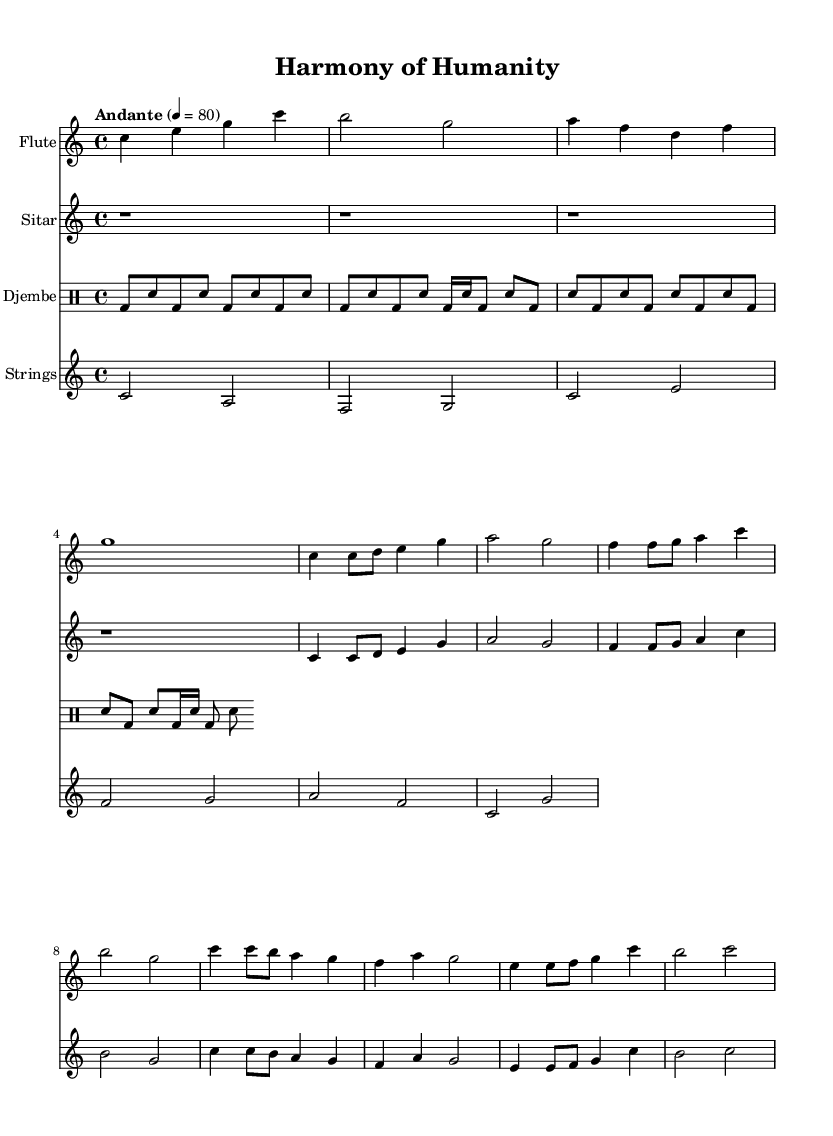What is the key signature of this music? The key signature is C major, which has no sharps or flats.
Answer: C major What is the time signature of this composition? The time signature is indicated as 4/4, meaning there are four beats in each measure and the quarter note gets one beat.
Answer: 4/4 What is the tempo marking for this piece? The piece is marked as "Andante," which typically indicates a moderately slow tempo.
Answer: Andante How many staves are there in the score? There are four distinct staves present in the score, each representing a different instrument.
Answer: Four Which instrument plays the first part of the score? The first staff in the score is designated for the flute, making it the first instrument featured.
Answer: Flute Which rhythm pattern is primarily used for the djembe? The djembe uses a basic pattern that features alternating bass and snare notes, creating a driving rhythmic feel.
Answer: Alternating bass and snare What musical theme do the instruments in this piece convey? The instruments collectively explore themes of unity and shared humanity through their harmonious melodies and rhythms.
Answer: Unity and shared humanity 